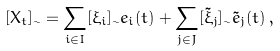<formula> <loc_0><loc_0><loc_500><loc_500>[ X _ { t } ] _ { \sim } = \sum _ { i \in I } [ \xi _ { i } ] _ { \sim } e _ { i } ( t ) + \sum _ { j \in J } [ \tilde { \xi } _ { j } ] _ { \sim } \tilde { e } _ { j } ( t ) \, ,</formula> 